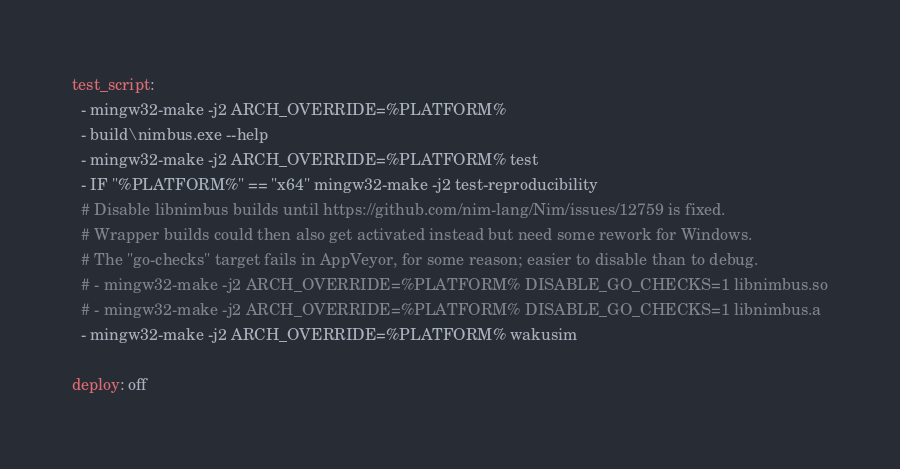<code> <loc_0><loc_0><loc_500><loc_500><_YAML_>
test_script:
  - mingw32-make -j2 ARCH_OVERRIDE=%PLATFORM%
  - build\nimbus.exe --help
  - mingw32-make -j2 ARCH_OVERRIDE=%PLATFORM% test
  - IF "%PLATFORM%" == "x64" mingw32-make -j2 test-reproducibility
  # Disable libnimbus builds until https://github.com/nim-lang/Nim/issues/12759 is fixed.
  # Wrapper builds could then also get activated instead but need some rework for Windows.
  # The "go-checks" target fails in AppVeyor, for some reason; easier to disable than to debug.
  # - mingw32-make -j2 ARCH_OVERRIDE=%PLATFORM% DISABLE_GO_CHECKS=1 libnimbus.so
  # - mingw32-make -j2 ARCH_OVERRIDE=%PLATFORM% DISABLE_GO_CHECKS=1 libnimbus.a
  - mingw32-make -j2 ARCH_OVERRIDE=%PLATFORM% wakusim

deploy: off

</code> 